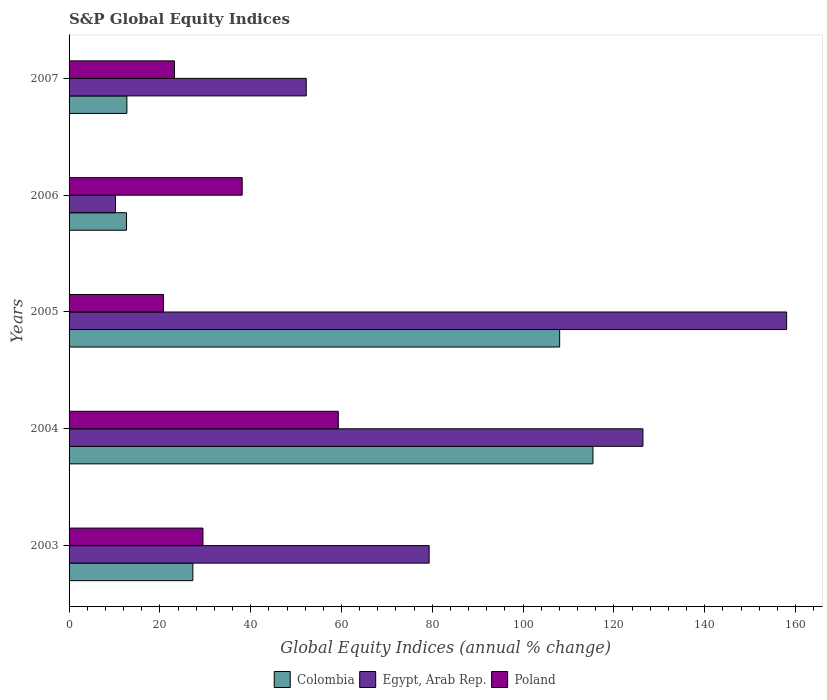How many different coloured bars are there?
Make the answer very short. 3. Are the number of bars per tick equal to the number of legend labels?
Your answer should be compact. Yes. How many bars are there on the 1st tick from the top?
Give a very brief answer. 3. What is the label of the 2nd group of bars from the top?
Your answer should be very brief. 2006. In how many cases, is the number of bars for a given year not equal to the number of legend labels?
Offer a very short reply. 0. What is the global equity indices in Egypt, Arab Rep. in 2003?
Keep it short and to the point. 79.31. Across all years, what is the maximum global equity indices in Colombia?
Provide a succinct answer. 115.39. Across all years, what is the minimum global equity indices in Colombia?
Ensure brevity in your answer.  12.66. In which year was the global equity indices in Egypt, Arab Rep. minimum?
Provide a short and direct response. 2006. What is the total global equity indices in Egypt, Arab Rep. in the graph?
Your response must be concise. 426.21. What is the difference between the global equity indices in Colombia in 2006 and that in 2007?
Offer a very short reply. -0.08. What is the difference between the global equity indices in Colombia in 2006 and the global equity indices in Egypt, Arab Rep. in 2007?
Provide a succinct answer. -39.58. What is the average global equity indices in Colombia per year?
Make the answer very short. 55.22. In the year 2006, what is the difference between the global equity indices in Colombia and global equity indices in Poland?
Ensure brevity in your answer.  -25.47. What is the ratio of the global equity indices in Egypt, Arab Rep. in 2003 to that in 2006?
Ensure brevity in your answer.  7.76. Is the global equity indices in Egypt, Arab Rep. in 2005 less than that in 2007?
Give a very brief answer. No. Is the difference between the global equity indices in Colombia in 2004 and 2005 greater than the difference between the global equity indices in Poland in 2004 and 2005?
Keep it short and to the point. No. What is the difference between the highest and the second highest global equity indices in Colombia?
Your response must be concise. 7.33. What is the difference between the highest and the lowest global equity indices in Poland?
Offer a terse response. 38.51. What does the 2nd bar from the top in 2005 represents?
Offer a very short reply. Egypt, Arab Rep. What does the 3rd bar from the bottom in 2004 represents?
Make the answer very short. Poland. Does the graph contain any zero values?
Make the answer very short. No. Does the graph contain grids?
Your response must be concise. No. How are the legend labels stacked?
Provide a short and direct response. Horizontal. What is the title of the graph?
Your answer should be compact. S&P Global Equity Indices. Does "Malawi" appear as one of the legend labels in the graph?
Provide a succinct answer. No. What is the label or title of the X-axis?
Provide a succinct answer. Global Equity Indices (annual % change). What is the label or title of the Y-axis?
Your answer should be compact. Years. What is the Global Equity Indices (annual % change) in Colombia in 2003?
Your response must be concise. 27.27. What is the Global Equity Indices (annual % change) of Egypt, Arab Rep. in 2003?
Provide a succinct answer. 79.31. What is the Global Equity Indices (annual % change) in Poland in 2003?
Provide a succinct answer. 29.49. What is the Global Equity Indices (annual % change) in Colombia in 2004?
Give a very brief answer. 115.39. What is the Global Equity Indices (annual % change) in Egypt, Arab Rep. in 2004?
Provide a succinct answer. 126.4. What is the Global Equity Indices (annual % change) of Poland in 2004?
Your response must be concise. 59.3. What is the Global Equity Indices (annual % change) in Colombia in 2005?
Make the answer very short. 108.06. What is the Global Equity Indices (annual % change) in Egypt, Arab Rep. in 2005?
Give a very brief answer. 158.05. What is the Global Equity Indices (annual % change) in Poland in 2005?
Your answer should be very brief. 20.79. What is the Global Equity Indices (annual % change) in Colombia in 2006?
Keep it short and to the point. 12.66. What is the Global Equity Indices (annual % change) in Egypt, Arab Rep. in 2006?
Your answer should be compact. 10.22. What is the Global Equity Indices (annual % change) in Poland in 2006?
Keep it short and to the point. 38.13. What is the Global Equity Indices (annual % change) of Colombia in 2007?
Offer a very short reply. 12.74. What is the Global Equity Indices (annual % change) of Egypt, Arab Rep. in 2007?
Offer a terse response. 52.24. What is the Global Equity Indices (annual % change) of Poland in 2007?
Offer a terse response. 23.22. Across all years, what is the maximum Global Equity Indices (annual % change) of Colombia?
Your answer should be very brief. 115.39. Across all years, what is the maximum Global Equity Indices (annual % change) of Egypt, Arab Rep.?
Offer a terse response. 158.05. Across all years, what is the maximum Global Equity Indices (annual % change) in Poland?
Give a very brief answer. 59.3. Across all years, what is the minimum Global Equity Indices (annual % change) in Colombia?
Provide a succinct answer. 12.66. Across all years, what is the minimum Global Equity Indices (annual % change) in Egypt, Arab Rep.?
Make the answer very short. 10.22. Across all years, what is the minimum Global Equity Indices (annual % change) of Poland?
Keep it short and to the point. 20.79. What is the total Global Equity Indices (annual % change) in Colombia in the graph?
Provide a succinct answer. 276.11. What is the total Global Equity Indices (annual % change) of Egypt, Arab Rep. in the graph?
Offer a terse response. 426.21. What is the total Global Equity Indices (annual % change) in Poland in the graph?
Provide a short and direct response. 170.93. What is the difference between the Global Equity Indices (annual % change) of Colombia in 2003 and that in 2004?
Your answer should be compact. -88.12. What is the difference between the Global Equity Indices (annual % change) in Egypt, Arab Rep. in 2003 and that in 2004?
Your answer should be very brief. -47.09. What is the difference between the Global Equity Indices (annual % change) of Poland in 2003 and that in 2004?
Your answer should be very brief. -29.81. What is the difference between the Global Equity Indices (annual % change) in Colombia in 2003 and that in 2005?
Your answer should be compact. -80.79. What is the difference between the Global Equity Indices (annual % change) in Egypt, Arab Rep. in 2003 and that in 2005?
Offer a very short reply. -78.74. What is the difference between the Global Equity Indices (annual % change) in Poland in 2003 and that in 2005?
Your response must be concise. 8.7. What is the difference between the Global Equity Indices (annual % change) of Colombia in 2003 and that in 2006?
Make the answer very short. 14.61. What is the difference between the Global Equity Indices (annual % change) in Egypt, Arab Rep. in 2003 and that in 2006?
Offer a terse response. 69.09. What is the difference between the Global Equity Indices (annual % change) of Poland in 2003 and that in 2006?
Provide a succinct answer. -8.64. What is the difference between the Global Equity Indices (annual % change) in Colombia in 2003 and that in 2007?
Ensure brevity in your answer.  14.53. What is the difference between the Global Equity Indices (annual % change) in Egypt, Arab Rep. in 2003 and that in 2007?
Give a very brief answer. 27.07. What is the difference between the Global Equity Indices (annual % change) in Poland in 2003 and that in 2007?
Your answer should be very brief. 6.27. What is the difference between the Global Equity Indices (annual % change) in Colombia in 2004 and that in 2005?
Your answer should be very brief. 7.33. What is the difference between the Global Equity Indices (annual % change) in Egypt, Arab Rep. in 2004 and that in 2005?
Your response must be concise. -31.65. What is the difference between the Global Equity Indices (annual % change) in Poland in 2004 and that in 2005?
Give a very brief answer. 38.51. What is the difference between the Global Equity Indices (annual % change) in Colombia in 2004 and that in 2006?
Ensure brevity in your answer.  102.73. What is the difference between the Global Equity Indices (annual % change) of Egypt, Arab Rep. in 2004 and that in 2006?
Provide a short and direct response. 116.18. What is the difference between the Global Equity Indices (annual % change) in Poland in 2004 and that in 2006?
Provide a short and direct response. 21.17. What is the difference between the Global Equity Indices (annual % change) of Colombia in 2004 and that in 2007?
Offer a terse response. 102.65. What is the difference between the Global Equity Indices (annual % change) in Egypt, Arab Rep. in 2004 and that in 2007?
Give a very brief answer. 74.16. What is the difference between the Global Equity Indices (annual % change) in Poland in 2004 and that in 2007?
Give a very brief answer. 36.08. What is the difference between the Global Equity Indices (annual % change) of Colombia in 2005 and that in 2006?
Provide a short and direct response. 95.4. What is the difference between the Global Equity Indices (annual % change) in Egypt, Arab Rep. in 2005 and that in 2006?
Make the answer very short. 147.83. What is the difference between the Global Equity Indices (annual % change) of Poland in 2005 and that in 2006?
Your answer should be compact. -17.34. What is the difference between the Global Equity Indices (annual % change) of Colombia in 2005 and that in 2007?
Your answer should be compact. 95.32. What is the difference between the Global Equity Indices (annual % change) of Egypt, Arab Rep. in 2005 and that in 2007?
Make the answer very short. 105.81. What is the difference between the Global Equity Indices (annual % change) of Poland in 2005 and that in 2007?
Your response must be concise. -2.43. What is the difference between the Global Equity Indices (annual % change) in Colombia in 2006 and that in 2007?
Your answer should be very brief. -0.08. What is the difference between the Global Equity Indices (annual % change) of Egypt, Arab Rep. in 2006 and that in 2007?
Your response must be concise. -42.02. What is the difference between the Global Equity Indices (annual % change) in Poland in 2006 and that in 2007?
Make the answer very short. 14.91. What is the difference between the Global Equity Indices (annual % change) in Colombia in 2003 and the Global Equity Indices (annual % change) in Egypt, Arab Rep. in 2004?
Give a very brief answer. -99.13. What is the difference between the Global Equity Indices (annual % change) in Colombia in 2003 and the Global Equity Indices (annual % change) in Poland in 2004?
Give a very brief answer. -32.03. What is the difference between the Global Equity Indices (annual % change) in Egypt, Arab Rep. in 2003 and the Global Equity Indices (annual % change) in Poland in 2004?
Offer a terse response. 20.01. What is the difference between the Global Equity Indices (annual % change) of Colombia in 2003 and the Global Equity Indices (annual % change) of Egypt, Arab Rep. in 2005?
Offer a very short reply. -130.78. What is the difference between the Global Equity Indices (annual % change) in Colombia in 2003 and the Global Equity Indices (annual % change) in Poland in 2005?
Provide a succinct answer. 6.48. What is the difference between the Global Equity Indices (annual % change) of Egypt, Arab Rep. in 2003 and the Global Equity Indices (annual % change) of Poland in 2005?
Your answer should be compact. 58.52. What is the difference between the Global Equity Indices (annual % change) in Colombia in 2003 and the Global Equity Indices (annual % change) in Egypt, Arab Rep. in 2006?
Provide a succinct answer. 17.05. What is the difference between the Global Equity Indices (annual % change) in Colombia in 2003 and the Global Equity Indices (annual % change) in Poland in 2006?
Give a very brief answer. -10.86. What is the difference between the Global Equity Indices (annual % change) in Egypt, Arab Rep. in 2003 and the Global Equity Indices (annual % change) in Poland in 2006?
Your response must be concise. 41.18. What is the difference between the Global Equity Indices (annual % change) in Colombia in 2003 and the Global Equity Indices (annual % change) in Egypt, Arab Rep. in 2007?
Keep it short and to the point. -24.97. What is the difference between the Global Equity Indices (annual % change) in Colombia in 2003 and the Global Equity Indices (annual % change) in Poland in 2007?
Ensure brevity in your answer.  4.05. What is the difference between the Global Equity Indices (annual % change) in Egypt, Arab Rep. in 2003 and the Global Equity Indices (annual % change) in Poland in 2007?
Provide a short and direct response. 56.09. What is the difference between the Global Equity Indices (annual % change) of Colombia in 2004 and the Global Equity Indices (annual % change) of Egypt, Arab Rep. in 2005?
Give a very brief answer. -42.66. What is the difference between the Global Equity Indices (annual % change) in Colombia in 2004 and the Global Equity Indices (annual % change) in Poland in 2005?
Provide a short and direct response. 94.6. What is the difference between the Global Equity Indices (annual % change) in Egypt, Arab Rep. in 2004 and the Global Equity Indices (annual % change) in Poland in 2005?
Your response must be concise. 105.61. What is the difference between the Global Equity Indices (annual % change) of Colombia in 2004 and the Global Equity Indices (annual % change) of Egypt, Arab Rep. in 2006?
Provide a succinct answer. 105.17. What is the difference between the Global Equity Indices (annual % change) in Colombia in 2004 and the Global Equity Indices (annual % change) in Poland in 2006?
Ensure brevity in your answer.  77.26. What is the difference between the Global Equity Indices (annual % change) in Egypt, Arab Rep. in 2004 and the Global Equity Indices (annual % change) in Poland in 2006?
Offer a very short reply. 88.27. What is the difference between the Global Equity Indices (annual % change) of Colombia in 2004 and the Global Equity Indices (annual % change) of Egypt, Arab Rep. in 2007?
Your answer should be very brief. 63.15. What is the difference between the Global Equity Indices (annual % change) of Colombia in 2004 and the Global Equity Indices (annual % change) of Poland in 2007?
Keep it short and to the point. 92.17. What is the difference between the Global Equity Indices (annual % change) of Egypt, Arab Rep. in 2004 and the Global Equity Indices (annual % change) of Poland in 2007?
Keep it short and to the point. 103.18. What is the difference between the Global Equity Indices (annual % change) in Colombia in 2005 and the Global Equity Indices (annual % change) in Egypt, Arab Rep. in 2006?
Provide a short and direct response. 97.84. What is the difference between the Global Equity Indices (annual % change) in Colombia in 2005 and the Global Equity Indices (annual % change) in Poland in 2006?
Your answer should be very brief. 69.93. What is the difference between the Global Equity Indices (annual % change) of Egypt, Arab Rep. in 2005 and the Global Equity Indices (annual % change) of Poland in 2006?
Your answer should be very brief. 119.92. What is the difference between the Global Equity Indices (annual % change) in Colombia in 2005 and the Global Equity Indices (annual % change) in Egypt, Arab Rep. in 2007?
Offer a terse response. 55.82. What is the difference between the Global Equity Indices (annual % change) in Colombia in 2005 and the Global Equity Indices (annual % change) in Poland in 2007?
Keep it short and to the point. 84.83. What is the difference between the Global Equity Indices (annual % change) of Egypt, Arab Rep. in 2005 and the Global Equity Indices (annual % change) of Poland in 2007?
Offer a very short reply. 134.83. What is the difference between the Global Equity Indices (annual % change) of Colombia in 2006 and the Global Equity Indices (annual % change) of Egypt, Arab Rep. in 2007?
Give a very brief answer. -39.58. What is the difference between the Global Equity Indices (annual % change) in Colombia in 2006 and the Global Equity Indices (annual % change) in Poland in 2007?
Offer a very short reply. -10.56. What is the difference between the Global Equity Indices (annual % change) in Egypt, Arab Rep. in 2006 and the Global Equity Indices (annual % change) in Poland in 2007?
Your response must be concise. -13. What is the average Global Equity Indices (annual % change) in Colombia per year?
Offer a very short reply. 55.22. What is the average Global Equity Indices (annual % change) in Egypt, Arab Rep. per year?
Provide a short and direct response. 85.24. What is the average Global Equity Indices (annual % change) in Poland per year?
Offer a terse response. 34.19. In the year 2003, what is the difference between the Global Equity Indices (annual % change) of Colombia and Global Equity Indices (annual % change) of Egypt, Arab Rep.?
Your answer should be very brief. -52.04. In the year 2003, what is the difference between the Global Equity Indices (annual % change) in Colombia and Global Equity Indices (annual % change) in Poland?
Offer a very short reply. -2.22. In the year 2003, what is the difference between the Global Equity Indices (annual % change) of Egypt, Arab Rep. and Global Equity Indices (annual % change) of Poland?
Provide a short and direct response. 49.82. In the year 2004, what is the difference between the Global Equity Indices (annual % change) of Colombia and Global Equity Indices (annual % change) of Egypt, Arab Rep.?
Your answer should be compact. -11.01. In the year 2004, what is the difference between the Global Equity Indices (annual % change) of Colombia and Global Equity Indices (annual % change) of Poland?
Provide a succinct answer. 56.09. In the year 2004, what is the difference between the Global Equity Indices (annual % change) in Egypt, Arab Rep. and Global Equity Indices (annual % change) in Poland?
Your answer should be very brief. 67.1. In the year 2005, what is the difference between the Global Equity Indices (annual % change) of Colombia and Global Equity Indices (annual % change) of Egypt, Arab Rep.?
Your response must be concise. -49.99. In the year 2005, what is the difference between the Global Equity Indices (annual % change) of Colombia and Global Equity Indices (annual % change) of Poland?
Your answer should be very brief. 87.27. In the year 2005, what is the difference between the Global Equity Indices (annual % change) of Egypt, Arab Rep. and Global Equity Indices (annual % change) of Poland?
Your answer should be compact. 137.26. In the year 2006, what is the difference between the Global Equity Indices (annual % change) of Colombia and Global Equity Indices (annual % change) of Egypt, Arab Rep.?
Make the answer very short. 2.44. In the year 2006, what is the difference between the Global Equity Indices (annual % change) of Colombia and Global Equity Indices (annual % change) of Poland?
Provide a short and direct response. -25.47. In the year 2006, what is the difference between the Global Equity Indices (annual % change) in Egypt, Arab Rep. and Global Equity Indices (annual % change) in Poland?
Give a very brief answer. -27.91. In the year 2007, what is the difference between the Global Equity Indices (annual % change) in Colombia and Global Equity Indices (annual % change) in Egypt, Arab Rep.?
Your answer should be very brief. -39.5. In the year 2007, what is the difference between the Global Equity Indices (annual % change) of Colombia and Global Equity Indices (annual % change) of Poland?
Offer a terse response. -10.49. In the year 2007, what is the difference between the Global Equity Indices (annual % change) in Egypt, Arab Rep. and Global Equity Indices (annual % change) in Poland?
Ensure brevity in your answer.  29.02. What is the ratio of the Global Equity Indices (annual % change) in Colombia in 2003 to that in 2004?
Your answer should be compact. 0.24. What is the ratio of the Global Equity Indices (annual % change) of Egypt, Arab Rep. in 2003 to that in 2004?
Give a very brief answer. 0.63. What is the ratio of the Global Equity Indices (annual % change) of Poland in 2003 to that in 2004?
Keep it short and to the point. 0.5. What is the ratio of the Global Equity Indices (annual % change) in Colombia in 2003 to that in 2005?
Your response must be concise. 0.25. What is the ratio of the Global Equity Indices (annual % change) in Egypt, Arab Rep. in 2003 to that in 2005?
Provide a short and direct response. 0.5. What is the ratio of the Global Equity Indices (annual % change) of Poland in 2003 to that in 2005?
Ensure brevity in your answer.  1.42. What is the ratio of the Global Equity Indices (annual % change) in Colombia in 2003 to that in 2006?
Offer a very short reply. 2.15. What is the ratio of the Global Equity Indices (annual % change) in Egypt, Arab Rep. in 2003 to that in 2006?
Give a very brief answer. 7.76. What is the ratio of the Global Equity Indices (annual % change) of Poland in 2003 to that in 2006?
Keep it short and to the point. 0.77. What is the ratio of the Global Equity Indices (annual % change) of Colombia in 2003 to that in 2007?
Your response must be concise. 2.14. What is the ratio of the Global Equity Indices (annual % change) in Egypt, Arab Rep. in 2003 to that in 2007?
Your answer should be very brief. 1.52. What is the ratio of the Global Equity Indices (annual % change) of Poland in 2003 to that in 2007?
Ensure brevity in your answer.  1.27. What is the ratio of the Global Equity Indices (annual % change) in Colombia in 2004 to that in 2005?
Provide a short and direct response. 1.07. What is the ratio of the Global Equity Indices (annual % change) in Egypt, Arab Rep. in 2004 to that in 2005?
Provide a short and direct response. 0.8. What is the ratio of the Global Equity Indices (annual % change) in Poland in 2004 to that in 2005?
Your response must be concise. 2.85. What is the ratio of the Global Equity Indices (annual % change) of Colombia in 2004 to that in 2006?
Give a very brief answer. 9.12. What is the ratio of the Global Equity Indices (annual % change) in Egypt, Arab Rep. in 2004 to that in 2006?
Give a very brief answer. 12.37. What is the ratio of the Global Equity Indices (annual % change) in Poland in 2004 to that in 2006?
Provide a succinct answer. 1.56. What is the ratio of the Global Equity Indices (annual % change) of Colombia in 2004 to that in 2007?
Keep it short and to the point. 9.06. What is the ratio of the Global Equity Indices (annual % change) in Egypt, Arab Rep. in 2004 to that in 2007?
Offer a very short reply. 2.42. What is the ratio of the Global Equity Indices (annual % change) of Poland in 2004 to that in 2007?
Make the answer very short. 2.55. What is the ratio of the Global Equity Indices (annual % change) in Colombia in 2005 to that in 2006?
Offer a terse response. 8.54. What is the ratio of the Global Equity Indices (annual % change) of Egypt, Arab Rep. in 2005 to that in 2006?
Your answer should be compact. 15.47. What is the ratio of the Global Equity Indices (annual % change) of Poland in 2005 to that in 2006?
Ensure brevity in your answer.  0.55. What is the ratio of the Global Equity Indices (annual % change) of Colombia in 2005 to that in 2007?
Your response must be concise. 8.48. What is the ratio of the Global Equity Indices (annual % change) of Egypt, Arab Rep. in 2005 to that in 2007?
Offer a terse response. 3.03. What is the ratio of the Global Equity Indices (annual % change) in Poland in 2005 to that in 2007?
Offer a very short reply. 0.9. What is the ratio of the Global Equity Indices (annual % change) of Colombia in 2006 to that in 2007?
Your answer should be compact. 0.99. What is the ratio of the Global Equity Indices (annual % change) of Egypt, Arab Rep. in 2006 to that in 2007?
Your response must be concise. 0.2. What is the ratio of the Global Equity Indices (annual % change) of Poland in 2006 to that in 2007?
Provide a succinct answer. 1.64. What is the difference between the highest and the second highest Global Equity Indices (annual % change) in Colombia?
Your answer should be compact. 7.33. What is the difference between the highest and the second highest Global Equity Indices (annual % change) in Egypt, Arab Rep.?
Offer a very short reply. 31.65. What is the difference between the highest and the second highest Global Equity Indices (annual % change) in Poland?
Make the answer very short. 21.17. What is the difference between the highest and the lowest Global Equity Indices (annual % change) in Colombia?
Offer a terse response. 102.73. What is the difference between the highest and the lowest Global Equity Indices (annual % change) in Egypt, Arab Rep.?
Make the answer very short. 147.83. What is the difference between the highest and the lowest Global Equity Indices (annual % change) of Poland?
Keep it short and to the point. 38.51. 